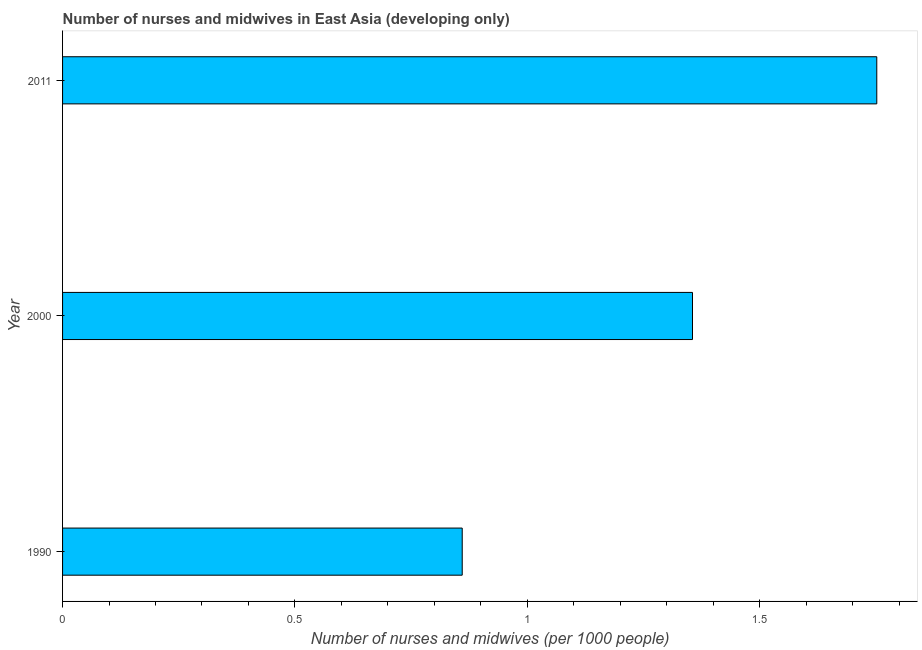Does the graph contain grids?
Give a very brief answer. No. What is the title of the graph?
Your answer should be compact. Number of nurses and midwives in East Asia (developing only). What is the label or title of the X-axis?
Your response must be concise. Number of nurses and midwives (per 1000 people). What is the number of nurses and midwives in 2011?
Offer a very short reply. 1.75. Across all years, what is the maximum number of nurses and midwives?
Your answer should be very brief. 1.75. Across all years, what is the minimum number of nurses and midwives?
Offer a terse response. 0.86. What is the sum of the number of nurses and midwives?
Ensure brevity in your answer.  3.97. What is the difference between the number of nurses and midwives in 1990 and 2000?
Offer a very short reply. -0.5. What is the average number of nurses and midwives per year?
Ensure brevity in your answer.  1.32. What is the median number of nurses and midwives?
Keep it short and to the point. 1.36. What is the ratio of the number of nurses and midwives in 1990 to that in 2000?
Provide a succinct answer. 0.63. Is the number of nurses and midwives in 1990 less than that in 2000?
Keep it short and to the point. Yes. What is the difference between the highest and the second highest number of nurses and midwives?
Your answer should be compact. 0.4. Is the sum of the number of nurses and midwives in 2000 and 2011 greater than the maximum number of nurses and midwives across all years?
Your answer should be very brief. Yes. What is the difference between the highest and the lowest number of nurses and midwives?
Your answer should be very brief. 0.89. How many bars are there?
Make the answer very short. 3. How many years are there in the graph?
Your answer should be very brief. 3. What is the difference between two consecutive major ticks on the X-axis?
Provide a succinct answer. 0.5. What is the Number of nurses and midwives (per 1000 people) in 1990?
Ensure brevity in your answer.  0.86. What is the Number of nurses and midwives (per 1000 people) of 2000?
Offer a terse response. 1.36. What is the Number of nurses and midwives (per 1000 people) in 2011?
Your answer should be compact. 1.75. What is the difference between the Number of nurses and midwives (per 1000 people) in 1990 and 2000?
Provide a succinct answer. -0.5. What is the difference between the Number of nurses and midwives (per 1000 people) in 1990 and 2011?
Your response must be concise. -0.89. What is the difference between the Number of nurses and midwives (per 1000 people) in 2000 and 2011?
Your response must be concise. -0.4. What is the ratio of the Number of nurses and midwives (per 1000 people) in 1990 to that in 2000?
Keep it short and to the point. 0.63. What is the ratio of the Number of nurses and midwives (per 1000 people) in 1990 to that in 2011?
Offer a terse response. 0.49. What is the ratio of the Number of nurses and midwives (per 1000 people) in 2000 to that in 2011?
Provide a succinct answer. 0.77. 